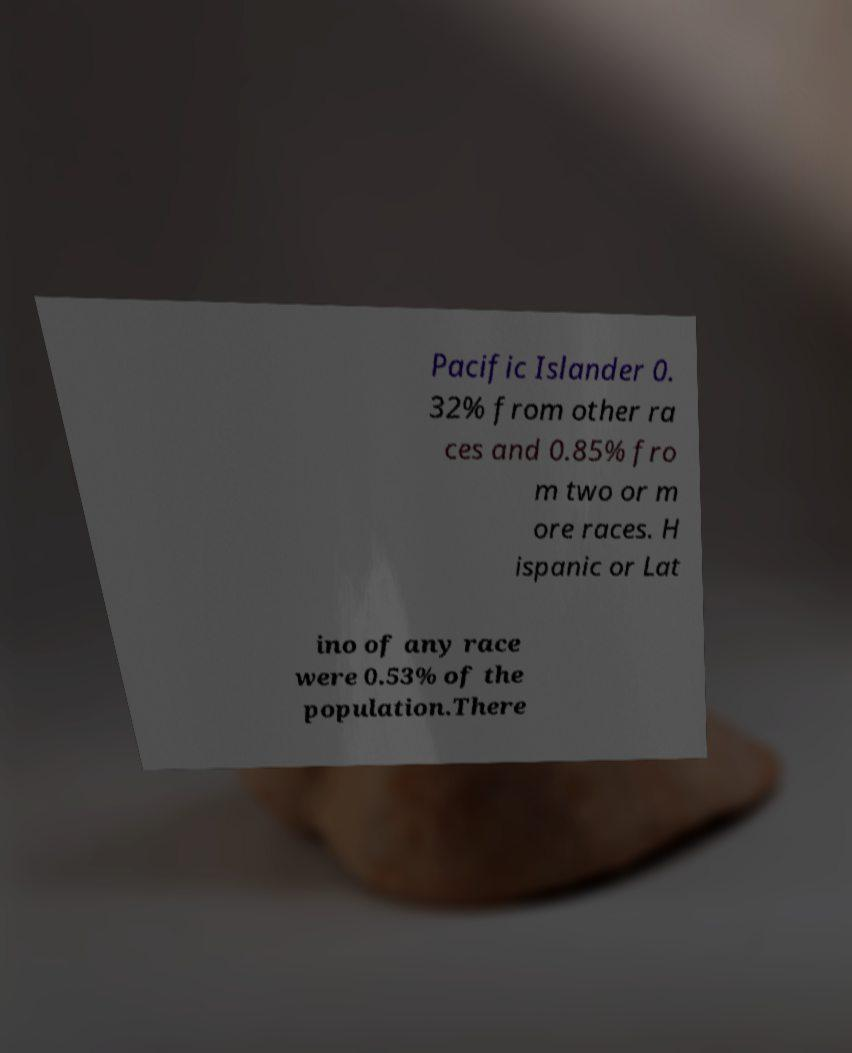There's text embedded in this image that I need extracted. Can you transcribe it verbatim? Pacific Islander 0. 32% from other ra ces and 0.85% fro m two or m ore races. H ispanic or Lat ino of any race were 0.53% of the population.There 